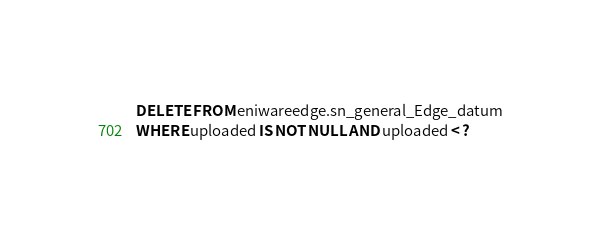Convert code to text. <code><loc_0><loc_0><loc_500><loc_500><_SQL_>DELETE FROM eniwareedge.sn_general_Edge_datum
WHERE uploaded IS NOT NULL AND uploaded < ?
</code> 